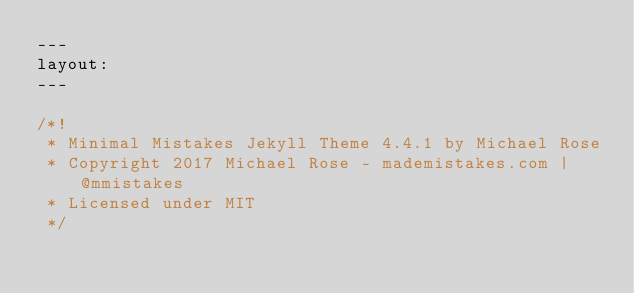Convert code to text. <code><loc_0><loc_0><loc_500><loc_500><_JavaScript_>---
layout:
---

/*!
 * Minimal Mistakes Jekyll Theme 4.4.1 by Michael Rose
 * Copyright 2017 Michael Rose - mademistakes.com | @mmistakes
 * Licensed under MIT
 */</code> 